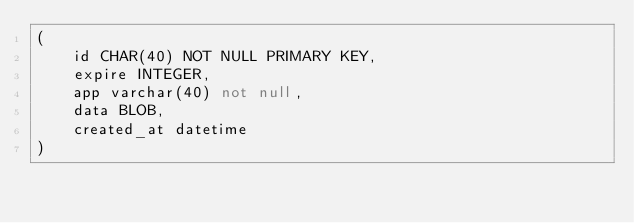Convert code to text. <code><loc_0><loc_0><loc_500><loc_500><_SQL_>(
    id CHAR(40) NOT NULL PRIMARY KEY,
    expire INTEGER,
    app varchar(40) not null,
    data BLOB,
    created_at datetime
)</code> 